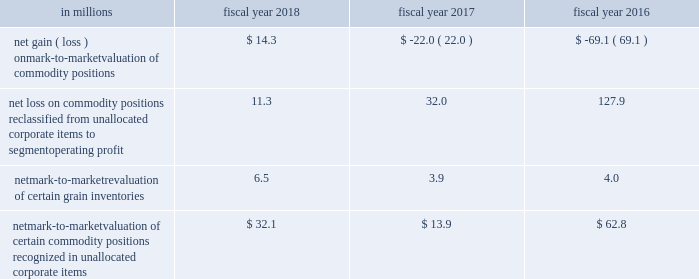Unallocated corporate items for fiscal 2018 , 2017 and 2016 included: .
Net mark-to-market valuation of certain commodity positions recognized in unallocated corporate items $ 32.1 $ 13.9 $ 62.8 as of may 27 , 2018 , the net notional value of commodity derivatives was $ 238.8 million , of which $ 147.9 million related to agricultural inputs and $ 90.9 million related to energy inputs .
These contracts relate to inputs that generally will be utilized within the next 12 months .
Interest rate risk we are exposed to interest rate volatility with regard to future issuances of fixed-rate debt , and existing and future issuances of floating-rate debt .
Primary exposures include u.s .
Treasury rates , libor , euribor , and commercial paper rates in the united states and europe .
We use interest rate swaps , forward-starting interest rate swaps , and treasury locks to hedge our exposure to interest rate changes , to reduce the volatility of our financing costs , and to achieve a desired proportion of fixed rate versus floating-rate debt , based on current and projected market conditions .
Generally under these swaps , we agree with a counterparty to exchange the difference between fixed-rate and floating-rate interest amounts based on an agreed upon notional principal amount .
Floating interest rate exposures 2014 floating-to-fixed interest rate swaps are accounted for as cash flow hedges , as are all hedges of forecasted issuances of debt .
Effectiveness is assessed based on either the perfectly effective hypothetical derivative method or changes in the present value of interest payments on the underlying debt .
Effective gains and losses deferred to aoci are reclassified into earnings over the life of the associated debt .
Ineffective gains and losses are recorded as net interest .
The amount of hedge ineffectiveness was a $ 2.6 million loss in fiscal 2018 , and less than $ 1 million in fiscal 2017 and 2016 .
Fixed interest rate exposures 2014 fixed-to-floating interest rate swaps are accounted for as fair value hedges with effectiveness assessed based on changes in the fair value of the underlying debt and derivatives , using incremental borrowing rates currently available on loans with similar terms and maturities .
Ineffective gains and losses on these derivatives and the underlying hedged items are recorded as net interest .
The amount of hedge ineffectiveness was a $ 3.4 million loss in fiscal 2018 , a $ 4.3 million gain in fiscal 2017 , and less than $ 1 million in fiscal 2016 .
In advance of planned debt financing related to the acquisition of blue buffalo , we entered into $ 3800.0 million of treasury locks due april 19 , 2018 , with an average fixed rate of 2.9 percent , of which $ 2300.0 million were entered into in the third quarter of fiscal 2018 and $ 1500.0 million were entered into in the fourth quarter of fiscal 2018 .
All of these treasury locks were cash settled for $ 43.9 million during the fourth quarter of fiscal 2018 , concurrent with the issuance of our $ 850.0 million 5.5-year fixed-rate notes , $ 800.0 million 7-year fixed- rate notes , $ 1400.0 million 10-year fixed-rate notes , $ 500.0 million 20-year fixed-rate notes , and $ 650.0 million 30-year fixed-rate notes .
In advance of planned debt financing , in fiscal 2018 , we entered into $ 500.0 million of treasury locks due october 15 , 2017 with an average fixed rate of 1.8 percent .
All of these treasury locks were cash settled for $ 3.7 million during the second quarter of fiscal 2018 , concurrent with the issuance of our $ 500.0 million 5-year fixed-rate notes. .
What portion of the net notional value of commodity derivatives is related to agricultural inputs? 
Computations: (147.9 / 238.8)
Answer: 0.61935. 